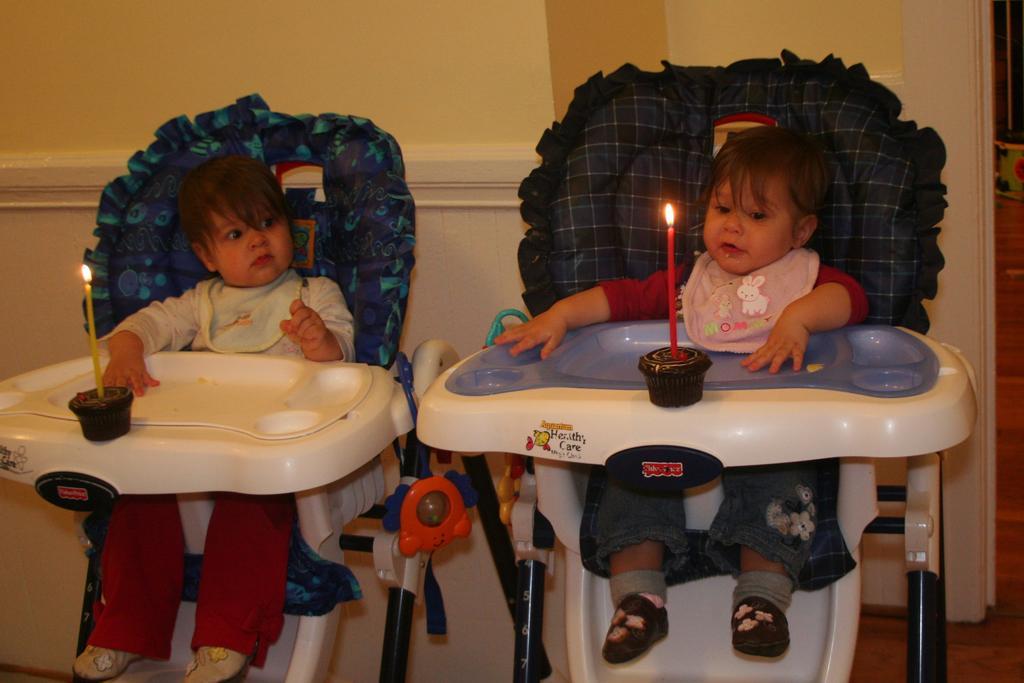Can you describe this image briefly? Two babies are sitting on the baby chairs. Two candles are there before them. 